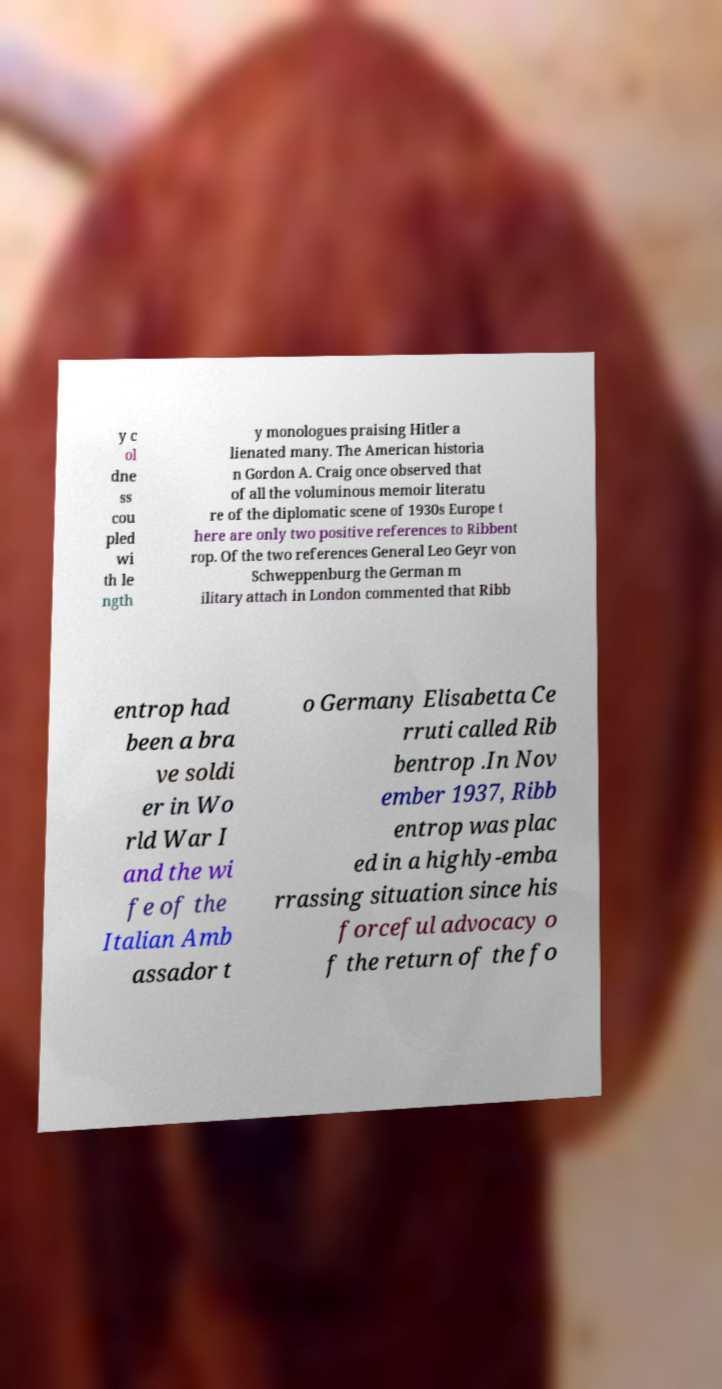Please identify and transcribe the text found in this image. y c ol dne ss cou pled wi th le ngth y monologues praising Hitler a lienated many. The American historia n Gordon A. Craig once observed that of all the voluminous memoir literatu re of the diplomatic scene of 1930s Europe t here are only two positive references to Ribbent rop. Of the two references General Leo Geyr von Schweppenburg the German m ilitary attach in London commented that Ribb entrop had been a bra ve soldi er in Wo rld War I and the wi fe of the Italian Amb assador t o Germany Elisabetta Ce rruti called Rib bentrop .In Nov ember 1937, Ribb entrop was plac ed in a highly-emba rrassing situation since his forceful advocacy o f the return of the fo 